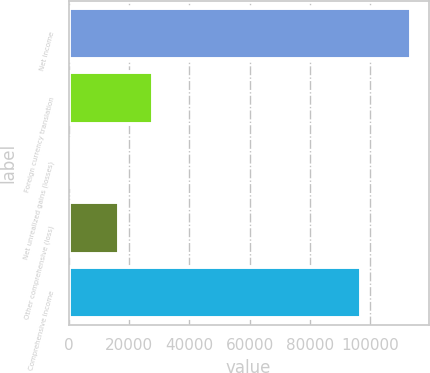<chart> <loc_0><loc_0><loc_500><loc_500><bar_chart><fcel>Net income<fcel>Foreign currency translation<fcel>Net unrealized gains (losses)<fcel>Other comprehensive (loss)<fcel>Comprehensive income<nl><fcel>113688<fcel>27967.5<fcel>13<fcel>16600<fcel>97088<nl></chart> 